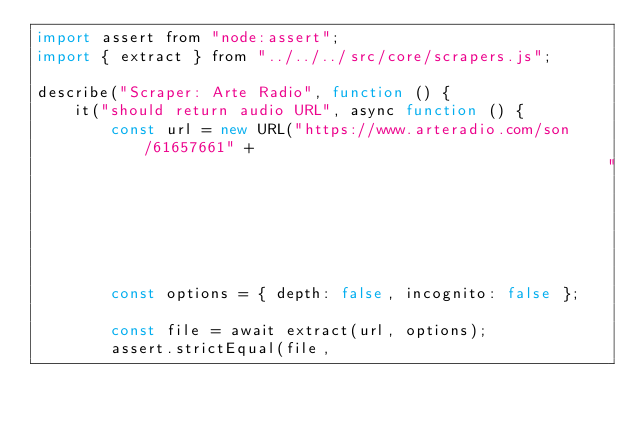Convert code to text. <code><loc_0><loc_0><loc_500><loc_500><_JavaScript_>import assert from "node:assert";
import { extract } from "../../../src/core/scrapers.js";

describe("Scraper: Arte Radio", function () {
    it("should return audio URL", async function () {
        const url = new URL("https://www.arteradio.com/son/61657661" +
                                                              "/fais_moi_ouir");
        const options = { depth: false, incognito: false };

        const file = await extract(url, options);
        assert.strictEqual(file,</code> 